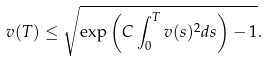Convert formula to latex. <formula><loc_0><loc_0><loc_500><loc_500>v ( T ) \leq \sqrt { \exp \left ( C \int _ { 0 } ^ { T } v ( s ) ^ { 2 } d s \right ) - 1 } .</formula> 